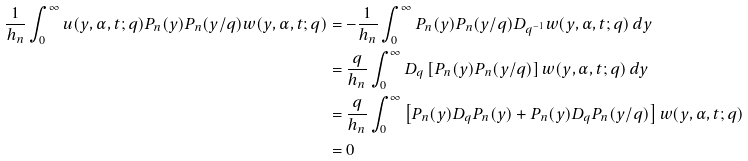Convert formula to latex. <formula><loc_0><loc_0><loc_500><loc_500>\frac { 1 } { h _ { n } } \int _ { 0 } ^ { \infty } u ( y , \alpha , t ; q ) P _ { n } ( y ) P _ { n } ( y / q ) w ( y , \alpha , t ; q ) & = - \frac { 1 } { h _ { n } } \int _ { 0 } ^ { \infty } P _ { n } ( y ) P _ { n } ( y / q ) D _ { q ^ { - 1 } } w ( y , \alpha , t ; q ) \, d y \\ & = \frac { q } { h _ { n } } \int _ { 0 } ^ { \infty } D _ { q } \left [ P _ { n } ( y ) P _ { n } ( y / q ) \right ] w ( y , \alpha , t ; q ) \, d y \\ & = \frac { q } { h _ { n } } \int _ { 0 } ^ { \infty } \left [ P _ { n } ( y ) D _ { q } P _ { n } ( y ) + P _ { n } ( y ) D _ { q } P _ { n } ( y / q ) \right ] w ( y , \alpha , t ; q ) \\ & = 0</formula> 